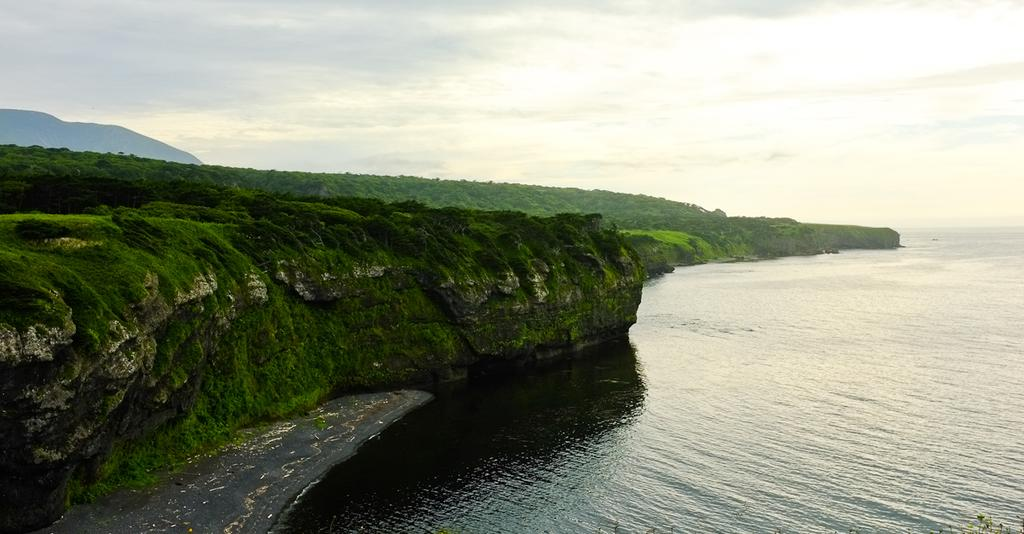What geographical feature is located on the left side of the image? There is a mountain on the left side of the image. What can be observed on the mountain in the image? The mountain is covered with plants and trees. What body of water is visible on the right side of the image? There is an ocean on the right side of the image. How would you describe the sky in the image? The sky is clear in the image. Can you tell me how many brothers are playing the game near the airport in the image? There is no airport, game, or brothers present in the image. 